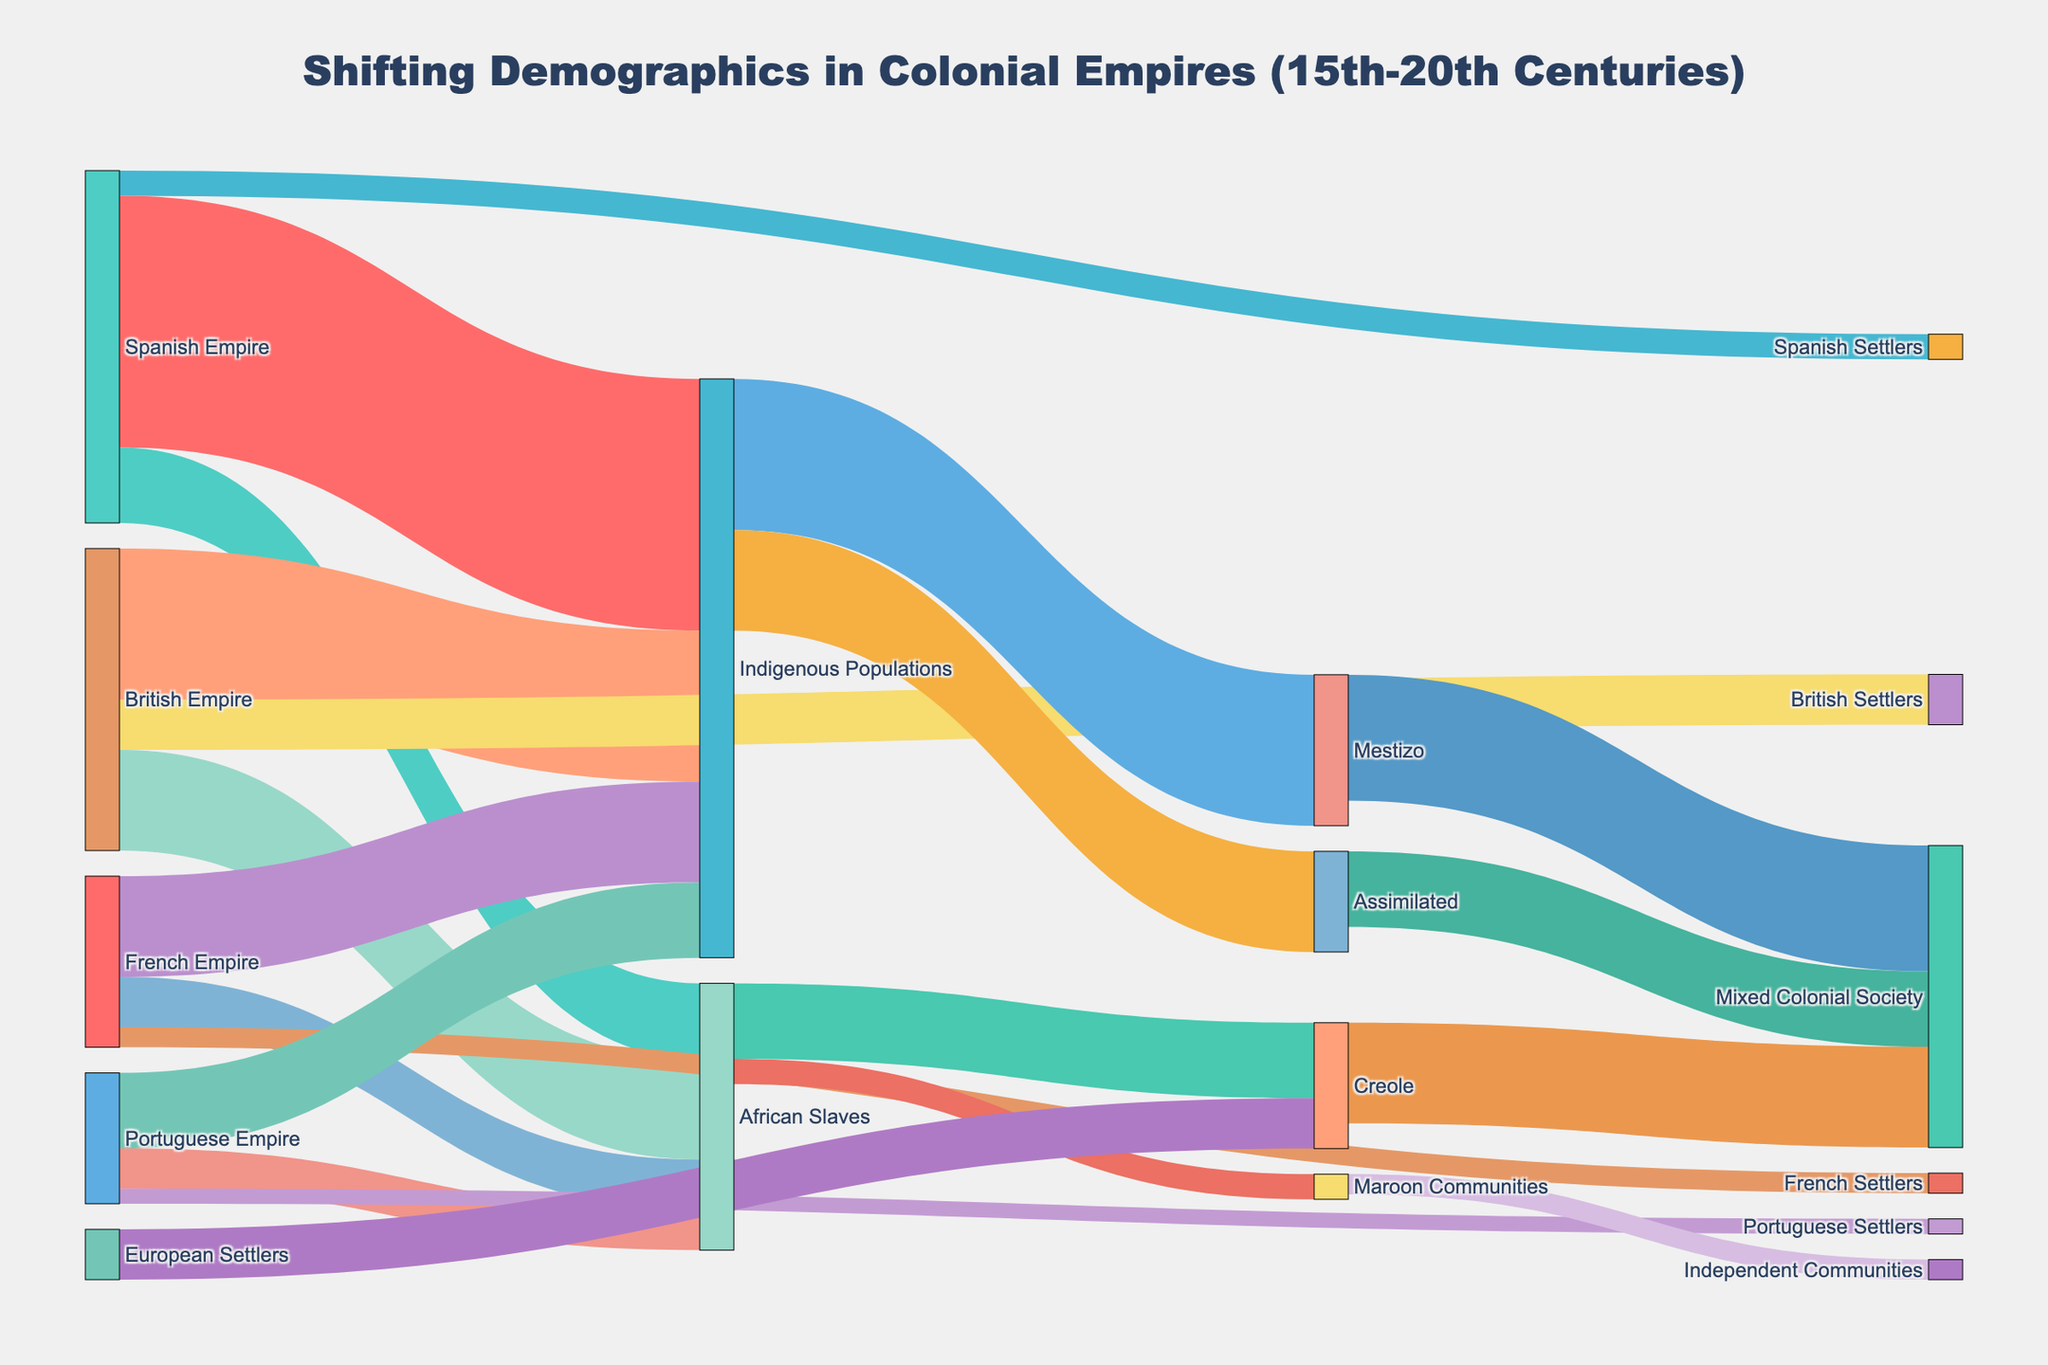What's the title of the figure? The title is displayed at the top of the Sankey Diagram.
Answer: Shifting Demographics in Colonial Empires (15th-20th Centuries) Which empire contributed the most to Indigenous Populations? By examining the links and their thickness, the Spanish Empire has the thickest link going to Indigenous Populations.
Answer: Spanish Empire How many people were part of the Creole group originating from African Slaves? The link value from African Slaves to Creole shows 1,500,000.
Answer: 1,500,000 What's the total number of settlers (combining Spanish, British, French, and Portuguese)? Sum the values of Spanish Settlers (500,000), British Settlers (1,000,000), French Settlers (400,000), and Portuguese Settlers (300,000). 500,000 + 1,000,000 + 400,000 + 300,000 = 2,200,000
Answer: 2,200,000 How many people transitioned from Mestizo to Mixed Colonial Society? The value on the link between Mestizo and Mixed Colonial Society is 2,500,000.
Answer: 2,500,000 Compare the number of African Slaves brought to British and French Empires. Which one had more and by how much? The British Empire brought 2,000,000 African Slaves, while the French Empire brought 1,000,000. The difference is 2,000,000 - 1,000,000 = 1,000,000.
Answer: British Empire, by 1,000,000 Which pathways contribute to the Mixed Colonial Society and what's their total value? Examine paths leading to Mixed Colonial Society: Mestizo (2,500,000), Creole (2,000,000), and Assimilated (1,500,000). Total = 2,500,000 + 2,000,000 + 1,500,000 = 6,000,000.
Answer: 6,000,000 What is the total value of the Indigenous Populations transitioning to Mestizo and Assimilated? Combine the values of Indigenous Populations to Mestizo (3,000,000) and Indigenous Populations to Assimilated (2,000,000). Total = 3,000,000 + 2,000,000 = 5,000,000.
Answer: 5,000,000 